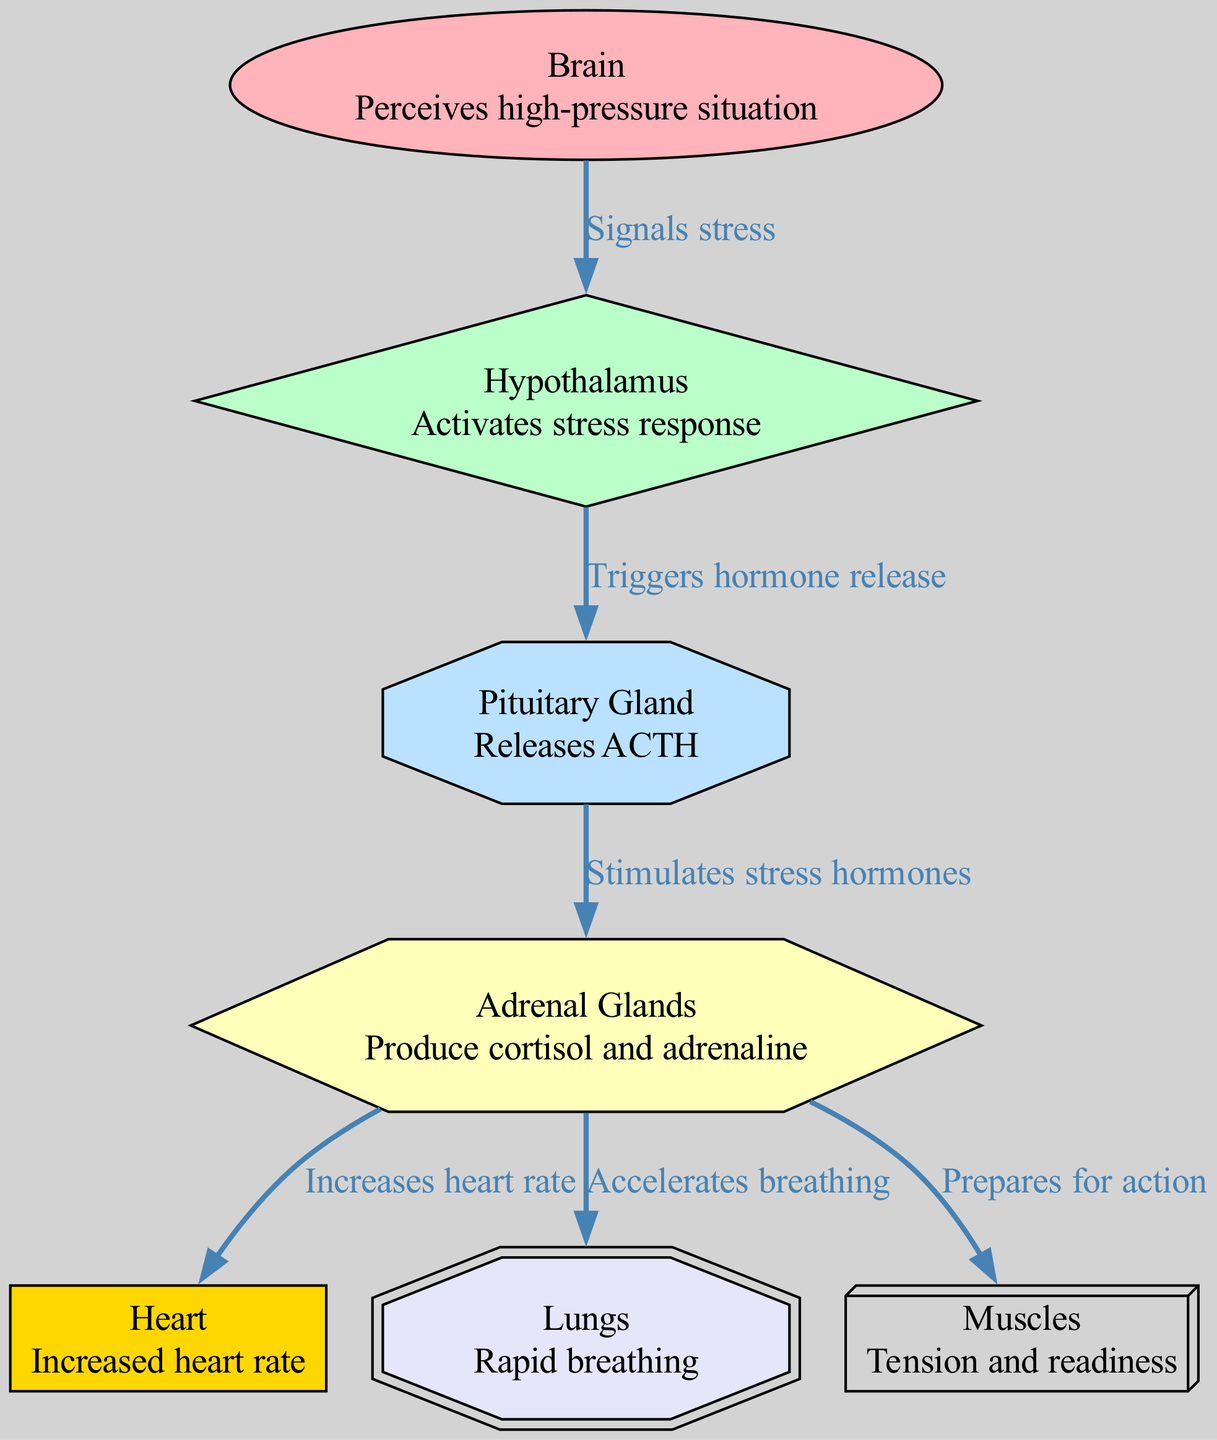What is the role of the hypothalamus? The hypothalamus activates the stress response, as indicated by its description in the diagram.
Answer: Activates stress response How many nodes are present in the diagram? By counting the nodes listed in the diagram, there are a total of seven distinct nodes.
Answer: 7 Which organ is responsible for increased heart rate? The adrenal glands are labeled in the diagram to indicate they increase the heart rate, making them the responsible organ for this function.
Answer: Adrenal Glands What signals the stress response in the body? The brain perceives the high-pressure situation and signals the stress response, which is clearly stated in the diagram.
Answer: Brain What hormone does the pituitary gland release? The diagram specifies that the pituitary gland releases ACTH, which stands for adrenocorticotropic hormone.
Answer: ACTH How do the adrenal glands affect breathing? The adrenal glands accelerate the breathing rate, which is explicitly shown in the diagram's connections to the lungs.
Answer: Accelerates breathing Which nodes are directly impacted by the adrenal glands? The adrenal glands impact the heart, lungs, and muscles directly, as seen through the edges connecting to these nodes.
Answer: Heart, Lungs, Muscles What is the relationship between the hypothalamus and the pituitary gland? The relationship is that the hypothalamus triggers hormone release in the pituitary gland, as specified in the diagram.
Answer: Triggers hormone release What type of diagram is used to represent the stress response? The diagram is a biomedical diagram, specifically focusing on the physiological aspects of the stress response.
Answer: Biomedical Diagram 